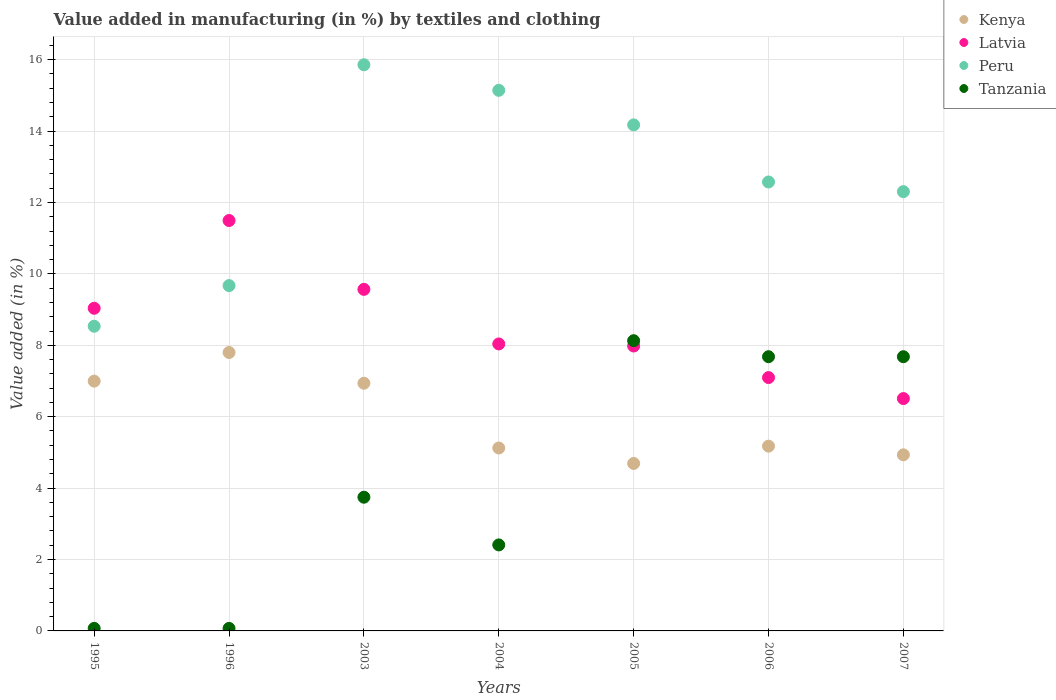How many different coloured dotlines are there?
Provide a short and direct response. 4. Is the number of dotlines equal to the number of legend labels?
Ensure brevity in your answer.  Yes. What is the percentage of value added in manufacturing by textiles and clothing in Latvia in 1996?
Give a very brief answer. 11.5. Across all years, what is the maximum percentage of value added in manufacturing by textiles and clothing in Latvia?
Ensure brevity in your answer.  11.5. Across all years, what is the minimum percentage of value added in manufacturing by textiles and clothing in Latvia?
Your response must be concise. 6.51. What is the total percentage of value added in manufacturing by textiles and clothing in Tanzania in the graph?
Keep it short and to the point. 29.79. What is the difference between the percentage of value added in manufacturing by textiles and clothing in Tanzania in 1995 and that in 2005?
Offer a very short reply. -8.06. What is the difference between the percentage of value added in manufacturing by textiles and clothing in Latvia in 1995 and the percentage of value added in manufacturing by textiles and clothing in Tanzania in 2007?
Ensure brevity in your answer.  1.36. What is the average percentage of value added in manufacturing by textiles and clothing in Tanzania per year?
Ensure brevity in your answer.  4.26. In the year 1996, what is the difference between the percentage of value added in manufacturing by textiles and clothing in Peru and percentage of value added in manufacturing by textiles and clothing in Kenya?
Your response must be concise. 1.87. What is the ratio of the percentage of value added in manufacturing by textiles and clothing in Kenya in 1995 to that in 2004?
Your answer should be very brief. 1.37. What is the difference between the highest and the second highest percentage of value added in manufacturing by textiles and clothing in Latvia?
Give a very brief answer. 1.93. What is the difference between the highest and the lowest percentage of value added in manufacturing by textiles and clothing in Tanzania?
Ensure brevity in your answer.  8.06. In how many years, is the percentage of value added in manufacturing by textiles and clothing in Latvia greater than the average percentage of value added in manufacturing by textiles and clothing in Latvia taken over all years?
Provide a succinct answer. 3. Is it the case that in every year, the sum of the percentage of value added in manufacturing by textiles and clothing in Peru and percentage of value added in manufacturing by textiles and clothing in Tanzania  is greater than the sum of percentage of value added in manufacturing by textiles and clothing in Latvia and percentage of value added in manufacturing by textiles and clothing in Kenya?
Keep it short and to the point. No. Does the percentage of value added in manufacturing by textiles and clothing in Peru monotonically increase over the years?
Ensure brevity in your answer.  No. Is the percentage of value added in manufacturing by textiles and clothing in Latvia strictly greater than the percentage of value added in manufacturing by textiles and clothing in Peru over the years?
Give a very brief answer. No. How many years are there in the graph?
Your response must be concise. 7. Are the values on the major ticks of Y-axis written in scientific E-notation?
Your answer should be very brief. No. Does the graph contain grids?
Keep it short and to the point. Yes. Where does the legend appear in the graph?
Offer a very short reply. Top right. How are the legend labels stacked?
Your answer should be very brief. Vertical. What is the title of the graph?
Offer a very short reply. Value added in manufacturing (in %) by textiles and clothing. Does "Bangladesh" appear as one of the legend labels in the graph?
Your response must be concise. No. What is the label or title of the X-axis?
Your answer should be very brief. Years. What is the label or title of the Y-axis?
Give a very brief answer. Value added (in %). What is the Value added (in %) of Kenya in 1995?
Provide a succinct answer. 7. What is the Value added (in %) in Latvia in 1995?
Your answer should be very brief. 9.04. What is the Value added (in %) in Peru in 1995?
Your answer should be compact. 8.53. What is the Value added (in %) in Tanzania in 1995?
Offer a terse response. 0.07. What is the Value added (in %) of Kenya in 1996?
Give a very brief answer. 7.8. What is the Value added (in %) in Latvia in 1996?
Offer a terse response. 11.5. What is the Value added (in %) in Peru in 1996?
Offer a very short reply. 9.67. What is the Value added (in %) in Tanzania in 1996?
Keep it short and to the point. 0.07. What is the Value added (in %) of Kenya in 2003?
Offer a very short reply. 6.94. What is the Value added (in %) in Latvia in 2003?
Keep it short and to the point. 9.57. What is the Value added (in %) in Peru in 2003?
Provide a succinct answer. 15.86. What is the Value added (in %) of Tanzania in 2003?
Your response must be concise. 3.74. What is the Value added (in %) in Kenya in 2004?
Give a very brief answer. 5.12. What is the Value added (in %) of Latvia in 2004?
Keep it short and to the point. 8.04. What is the Value added (in %) in Peru in 2004?
Your answer should be very brief. 15.14. What is the Value added (in %) of Tanzania in 2004?
Your answer should be compact. 2.41. What is the Value added (in %) of Kenya in 2005?
Ensure brevity in your answer.  4.69. What is the Value added (in %) of Latvia in 2005?
Make the answer very short. 7.98. What is the Value added (in %) of Peru in 2005?
Offer a very short reply. 14.17. What is the Value added (in %) of Tanzania in 2005?
Offer a very short reply. 8.13. What is the Value added (in %) in Kenya in 2006?
Make the answer very short. 5.18. What is the Value added (in %) in Latvia in 2006?
Give a very brief answer. 7.1. What is the Value added (in %) in Peru in 2006?
Keep it short and to the point. 12.57. What is the Value added (in %) of Tanzania in 2006?
Provide a succinct answer. 7.68. What is the Value added (in %) in Kenya in 2007?
Keep it short and to the point. 4.93. What is the Value added (in %) of Latvia in 2007?
Offer a very short reply. 6.51. What is the Value added (in %) in Peru in 2007?
Offer a very short reply. 12.3. What is the Value added (in %) in Tanzania in 2007?
Offer a terse response. 7.68. Across all years, what is the maximum Value added (in %) of Kenya?
Offer a terse response. 7.8. Across all years, what is the maximum Value added (in %) of Latvia?
Give a very brief answer. 11.5. Across all years, what is the maximum Value added (in %) of Peru?
Your answer should be very brief. 15.86. Across all years, what is the maximum Value added (in %) in Tanzania?
Your answer should be very brief. 8.13. Across all years, what is the minimum Value added (in %) in Kenya?
Provide a succinct answer. 4.69. Across all years, what is the minimum Value added (in %) of Latvia?
Your answer should be very brief. 6.51. Across all years, what is the minimum Value added (in %) in Peru?
Offer a very short reply. 8.53. Across all years, what is the minimum Value added (in %) of Tanzania?
Your response must be concise. 0.07. What is the total Value added (in %) of Kenya in the graph?
Your answer should be very brief. 41.65. What is the total Value added (in %) of Latvia in the graph?
Ensure brevity in your answer.  59.72. What is the total Value added (in %) of Peru in the graph?
Ensure brevity in your answer.  88.26. What is the total Value added (in %) in Tanzania in the graph?
Offer a very short reply. 29.79. What is the difference between the Value added (in %) of Kenya in 1995 and that in 1996?
Provide a short and direct response. -0.8. What is the difference between the Value added (in %) of Latvia in 1995 and that in 1996?
Provide a short and direct response. -2.46. What is the difference between the Value added (in %) in Peru in 1995 and that in 1996?
Offer a very short reply. -1.14. What is the difference between the Value added (in %) of Tanzania in 1995 and that in 1996?
Keep it short and to the point. 0. What is the difference between the Value added (in %) of Kenya in 1995 and that in 2003?
Your answer should be very brief. 0.06. What is the difference between the Value added (in %) in Latvia in 1995 and that in 2003?
Make the answer very short. -0.53. What is the difference between the Value added (in %) in Peru in 1995 and that in 2003?
Your answer should be compact. -7.32. What is the difference between the Value added (in %) of Tanzania in 1995 and that in 2003?
Make the answer very short. -3.67. What is the difference between the Value added (in %) of Kenya in 1995 and that in 2004?
Your answer should be compact. 1.87. What is the difference between the Value added (in %) of Latvia in 1995 and that in 2004?
Your response must be concise. 1. What is the difference between the Value added (in %) in Peru in 1995 and that in 2004?
Offer a terse response. -6.61. What is the difference between the Value added (in %) of Tanzania in 1995 and that in 2004?
Provide a succinct answer. -2.34. What is the difference between the Value added (in %) of Kenya in 1995 and that in 2005?
Provide a succinct answer. 2.31. What is the difference between the Value added (in %) of Latvia in 1995 and that in 2005?
Provide a succinct answer. 1.06. What is the difference between the Value added (in %) in Peru in 1995 and that in 2005?
Your response must be concise. -5.64. What is the difference between the Value added (in %) of Tanzania in 1995 and that in 2005?
Your answer should be compact. -8.06. What is the difference between the Value added (in %) in Kenya in 1995 and that in 2006?
Ensure brevity in your answer.  1.82. What is the difference between the Value added (in %) in Latvia in 1995 and that in 2006?
Provide a succinct answer. 1.94. What is the difference between the Value added (in %) in Peru in 1995 and that in 2006?
Make the answer very short. -4.04. What is the difference between the Value added (in %) of Tanzania in 1995 and that in 2006?
Ensure brevity in your answer.  -7.61. What is the difference between the Value added (in %) of Kenya in 1995 and that in 2007?
Make the answer very short. 2.06. What is the difference between the Value added (in %) in Latvia in 1995 and that in 2007?
Provide a short and direct response. 2.53. What is the difference between the Value added (in %) in Peru in 1995 and that in 2007?
Ensure brevity in your answer.  -3.77. What is the difference between the Value added (in %) of Tanzania in 1995 and that in 2007?
Your answer should be very brief. -7.61. What is the difference between the Value added (in %) of Kenya in 1996 and that in 2003?
Your answer should be very brief. 0.86. What is the difference between the Value added (in %) in Latvia in 1996 and that in 2003?
Offer a terse response. 1.93. What is the difference between the Value added (in %) of Peru in 1996 and that in 2003?
Keep it short and to the point. -6.19. What is the difference between the Value added (in %) of Tanzania in 1996 and that in 2003?
Your answer should be compact. -3.67. What is the difference between the Value added (in %) of Kenya in 1996 and that in 2004?
Your response must be concise. 2.67. What is the difference between the Value added (in %) in Latvia in 1996 and that in 2004?
Make the answer very short. 3.46. What is the difference between the Value added (in %) of Peru in 1996 and that in 2004?
Provide a succinct answer. -5.47. What is the difference between the Value added (in %) in Tanzania in 1996 and that in 2004?
Give a very brief answer. -2.34. What is the difference between the Value added (in %) of Kenya in 1996 and that in 2005?
Give a very brief answer. 3.11. What is the difference between the Value added (in %) of Latvia in 1996 and that in 2005?
Make the answer very short. 3.51. What is the difference between the Value added (in %) of Peru in 1996 and that in 2005?
Offer a very short reply. -4.5. What is the difference between the Value added (in %) in Tanzania in 1996 and that in 2005?
Offer a terse response. -8.06. What is the difference between the Value added (in %) of Kenya in 1996 and that in 2006?
Offer a terse response. 2.62. What is the difference between the Value added (in %) in Latvia in 1996 and that in 2006?
Provide a short and direct response. 4.4. What is the difference between the Value added (in %) in Peru in 1996 and that in 2006?
Keep it short and to the point. -2.9. What is the difference between the Value added (in %) in Tanzania in 1996 and that in 2006?
Offer a terse response. -7.61. What is the difference between the Value added (in %) of Kenya in 1996 and that in 2007?
Your answer should be compact. 2.87. What is the difference between the Value added (in %) in Latvia in 1996 and that in 2007?
Give a very brief answer. 4.99. What is the difference between the Value added (in %) of Peru in 1996 and that in 2007?
Ensure brevity in your answer.  -2.63. What is the difference between the Value added (in %) in Tanzania in 1996 and that in 2007?
Make the answer very short. -7.61. What is the difference between the Value added (in %) in Kenya in 2003 and that in 2004?
Your answer should be compact. 1.81. What is the difference between the Value added (in %) in Latvia in 2003 and that in 2004?
Your answer should be compact. 1.53. What is the difference between the Value added (in %) in Peru in 2003 and that in 2004?
Provide a short and direct response. 0.72. What is the difference between the Value added (in %) of Tanzania in 2003 and that in 2004?
Your response must be concise. 1.34. What is the difference between the Value added (in %) in Kenya in 2003 and that in 2005?
Your answer should be very brief. 2.25. What is the difference between the Value added (in %) of Latvia in 2003 and that in 2005?
Your answer should be compact. 1.59. What is the difference between the Value added (in %) in Peru in 2003 and that in 2005?
Your answer should be very brief. 1.68. What is the difference between the Value added (in %) of Tanzania in 2003 and that in 2005?
Your response must be concise. -4.38. What is the difference between the Value added (in %) in Kenya in 2003 and that in 2006?
Offer a terse response. 1.76. What is the difference between the Value added (in %) of Latvia in 2003 and that in 2006?
Keep it short and to the point. 2.47. What is the difference between the Value added (in %) in Peru in 2003 and that in 2006?
Your answer should be compact. 3.28. What is the difference between the Value added (in %) in Tanzania in 2003 and that in 2006?
Your answer should be very brief. -3.94. What is the difference between the Value added (in %) of Kenya in 2003 and that in 2007?
Your answer should be compact. 2.01. What is the difference between the Value added (in %) in Latvia in 2003 and that in 2007?
Your answer should be compact. 3.06. What is the difference between the Value added (in %) of Peru in 2003 and that in 2007?
Give a very brief answer. 3.55. What is the difference between the Value added (in %) of Tanzania in 2003 and that in 2007?
Ensure brevity in your answer.  -3.94. What is the difference between the Value added (in %) in Kenya in 2004 and that in 2005?
Offer a very short reply. 0.43. What is the difference between the Value added (in %) of Latvia in 2004 and that in 2005?
Offer a terse response. 0.06. What is the difference between the Value added (in %) in Tanzania in 2004 and that in 2005?
Offer a very short reply. -5.72. What is the difference between the Value added (in %) of Kenya in 2004 and that in 2006?
Make the answer very short. -0.05. What is the difference between the Value added (in %) in Latvia in 2004 and that in 2006?
Offer a very short reply. 0.94. What is the difference between the Value added (in %) of Peru in 2004 and that in 2006?
Your answer should be compact. 2.57. What is the difference between the Value added (in %) in Tanzania in 2004 and that in 2006?
Give a very brief answer. -5.27. What is the difference between the Value added (in %) in Kenya in 2004 and that in 2007?
Give a very brief answer. 0.19. What is the difference between the Value added (in %) of Latvia in 2004 and that in 2007?
Your response must be concise. 1.53. What is the difference between the Value added (in %) in Peru in 2004 and that in 2007?
Provide a short and direct response. 2.84. What is the difference between the Value added (in %) of Tanzania in 2004 and that in 2007?
Give a very brief answer. -5.27. What is the difference between the Value added (in %) of Kenya in 2005 and that in 2006?
Keep it short and to the point. -0.48. What is the difference between the Value added (in %) of Latvia in 2005 and that in 2006?
Provide a succinct answer. 0.88. What is the difference between the Value added (in %) in Peru in 2005 and that in 2006?
Offer a terse response. 1.6. What is the difference between the Value added (in %) of Tanzania in 2005 and that in 2006?
Your answer should be very brief. 0.45. What is the difference between the Value added (in %) in Kenya in 2005 and that in 2007?
Your response must be concise. -0.24. What is the difference between the Value added (in %) of Latvia in 2005 and that in 2007?
Give a very brief answer. 1.47. What is the difference between the Value added (in %) in Peru in 2005 and that in 2007?
Your answer should be compact. 1.87. What is the difference between the Value added (in %) of Tanzania in 2005 and that in 2007?
Make the answer very short. 0.45. What is the difference between the Value added (in %) in Kenya in 2006 and that in 2007?
Your response must be concise. 0.24. What is the difference between the Value added (in %) of Latvia in 2006 and that in 2007?
Your response must be concise. 0.59. What is the difference between the Value added (in %) of Peru in 2006 and that in 2007?
Your response must be concise. 0.27. What is the difference between the Value added (in %) of Kenya in 1995 and the Value added (in %) of Latvia in 1996?
Your response must be concise. -4.5. What is the difference between the Value added (in %) of Kenya in 1995 and the Value added (in %) of Peru in 1996?
Your answer should be very brief. -2.68. What is the difference between the Value added (in %) of Kenya in 1995 and the Value added (in %) of Tanzania in 1996?
Your response must be concise. 6.93. What is the difference between the Value added (in %) of Latvia in 1995 and the Value added (in %) of Peru in 1996?
Your answer should be compact. -0.63. What is the difference between the Value added (in %) of Latvia in 1995 and the Value added (in %) of Tanzania in 1996?
Offer a very short reply. 8.97. What is the difference between the Value added (in %) in Peru in 1995 and the Value added (in %) in Tanzania in 1996?
Make the answer very short. 8.46. What is the difference between the Value added (in %) in Kenya in 1995 and the Value added (in %) in Latvia in 2003?
Keep it short and to the point. -2.57. What is the difference between the Value added (in %) in Kenya in 1995 and the Value added (in %) in Peru in 2003?
Keep it short and to the point. -8.86. What is the difference between the Value added (in %) of Kenya in 1995 and the Value added (in %) of Tanzania in 2003?
Offer a very short reply. 3.25. What is the difference between the Value added (in %) in Latvia in 1995 and the Value added (in %) in Peru in 2003?
Provide a short and direct response. -6.82. What is the difference between the Value added (in %) of Latvia in 1995 and the Value added (in %) of Tanzania in 2003?
Your response must be concise. 5.29. What is the difference between the Value added (in %) in Peru in 1995 and the Value added (in %) in Tanzania in 2003?
Your answer should be compact. 4.79. What is the difference between the Value added (in %) of Kenya in 1995 and the Value added (in %) of Latvia in 2004?
Provide a succinct answer. -1.04. What is the difference between the Value added (in %) in Kenya in 1995 and the Value added (in %) in Peru in 2004?
Your response must be concise. -8.15. What is the difference between the Value added (in %) of Kenya in 1995 and the Value added (in %) of Tanzania in 2004?
Provide a succinct answer. 4.59. What is the difference between the Value added (in %) of Latvia in 1995 and the Value added (in %) of Peru in 2004?
Give a very brief answer. -6.1. What is the difference between the Value added (in %) of Latvia in 1995 and the Value added (in %) of Tanzania in 2004?
Your answer should be very brief. 6.63. What is the difference between the Value added (in %) in Peru in 1995 and the Value added (in %) in Tanzania in 2004?
Keep it short and to the point. 6.12. What is the difference between the Value added (in %) in Kenya in 1995 and the Value added (in %) in Latvia in 2005?
Ensure brevity in your answer.  -0.98. What is the difference between the Value added (in %) of Kenya in 1995 and the Value added (in %) of Peru in 2005?
Your answer should be very brief. -7.18. What is the difference between the Value added (in %) of Kenya in 1995 and the Value added (in %) of Tanzania in 2005?
Keep it short and to the point. -1.13. What is the difference between the Value added (in %) in Latvia in 1995 and the Value added (in %) in Peru in 2005?
Your answer should be very brief. -5.14. What is the difference between the Value added (in %) of Latvia in 1995 and the Value added (in %) of Tanzania in 2005?
Ensure brevity in your answer.  0.91. What is the difference between the Value added (in %) of Peru in 1995 and the Value added (in %) of Tanzania in 2005?
Offer a very short reply. 0.4. What is the difference between the Value added (in %) in Kenya in 1995 and the Value added (in %) in Peru in 2006?
Offer a terse response. -5.58. What is the difference between the Value added (in %) in Kenya in 1995 and the Value added (in %) in Tanzania in 2006?
Give a very brief answer. -0.68. What is the difference between the Value added (in %) of Latvia in 1995 and the Value added (in %) of Peru in 2006?
Ensure brevity in your answer.  -3.54. What is the difference between the Value added (in %) in Latvia in 1995 and the Value added (in %) in Tanzania in 2006?
Make the answer very short. 1.36. What is the difference between the Value added (in %) in Peru in 1995 and the Value added (in %) in Tanzania in 2006?
Give a very brief answer. 0.85. What is the difference between the Value added (in %) of Kenya in 1995 and the Value added (in %) of Latvia in 2007?
Your answer should be very brief. 0.49. What is the difference between the Value added (in %) of Kenya in 1995 and the Value added (in %) of Peru in 2007?
Keep it short and to the point. -5.31. What is the difference between the Value added (in %) of Kenya in 1995 and the Value added (in %) of Tanzania in 2007?
Offer a very short reply. -0.68. What is the difference between the Value added (in %) in Latvia in 1995 and the Value added (in %) in Peru in 2007?
Give a very brief answer. -3.27. What is the difference between the Value added (in %) of Latvia in 1995 and the Value added (in %) of Tanzania in 2007?
Give a very brief answer. 1.36. What is the difference between the Value added (in %) of Peru in 1995 and the Value added (in %) of Tanzania in 2007?
Make the answer very short. 0.85. What is the difference between the Value added (in %) of Kenya in 1996 and the Value added (in %) of Latvia in 2003?
Provide a short and direct response. -1.77. What is the difference between the Value added (in %) of Kenya in 1996 and the Value added (in %) of Peru in 2003?
Offer a very short reply. -8.06. What is the difference between the Value added (in %) of Kenya in 1996 and the Value added (in %) of Tanzania in 2003?
Your answer should be very brief. 4.05. What is the difference between the Value added (in %) in Latvia in 1996 and the Value added (in %) in Peru in 2003?
Provide a short and direct response. -4.36. What is the difference between the Value added (in %) of Latvia in 1996 and the Value added (in %) of Tanzania in 2003?
Provide a short and direct response. 7.75. What is the difference between the Value added (in %) in Peru in 1996 and the Value added (in %) in Tanzania in 2003?
Provide a succinct answer. 5.93. What is the difference between the Value added (in %) of Kenya in 1996 and the Value added (in %) of Latvia in 2004?
Provide a short and direct response. -0.24. What is the difference between the Value added (in %) in Kenya in 1996 and the Value added (in %) in Peru in 2004?
Offer a terse response. -7.34. What is the difference between the Value added (in %) of Kenya in 1996 and the Value added (in %) of Tanzania in 2004?
Your answer should be compact. 5.39. What is the difference between the Value added (in %) of Latvia in 1996 and the Value added (in %) of Peru in 2004?
Make the answer very short. -3.65. What is the difference between the Value added (in %) in Latvia in 1996 and the Value added (in %) in Tanzania in 2004?
Offer a very short reply. 9.09. What is the difference between the Value added (in %) of Peru in 1996 and the Value added (in %) of Tanzania in 2004?
Ensure brevity in your answer.  7.26. What is the difference between the Value added (in %) in Kenya in 1996 and the Value added (in %) in Latvia in 2005?
Give a very brief answer. -0.18. What is the difference between the Value added (in %) of Kenya in 1996 and the Value added (in %) of Peru in 2005?
Keep it short and to the point. -6.37. What is the difference between the Value added (in %) of Kenya in 1996 and the Value added (in %) of Tanzania in 2005?
Offer a very short reply. -0.33. What is the difference between the Value added (in %) in Latvia in 1996 and the Value added (in %) in Peru in 2005?
Give a very brief answer. -2.68. What is the difference between the Value added (in %) in Latvia in 1996 and the Value added (in %) in Tanzania in 2005?
Provide a short and direct response. 3.37. What is the difference between the Value added (in %) in Peru in 1996 and the Value added (in %) in Tanzania in 2005?
Provide a succinct answer. 1.54. What is the difference between the Value added (in %) of Kenya in 1996 and the Value added (in %) of Latvia in 2006?
Provide a short and direct response. 0.7. What is the difference between the Value added (in %) in Kenya in 1996 and the Value added (in %) in Peru in 2006?
Offer a terse response. -4.78. What is the difference between the Value added (in %) of Kenya in 1996 and the Value added (in %) of Tanzania in 2006?
Provide a succinct answer. 0.12. What is the difference between the Value added (in %) of Latvia in 1996 and the Value added (in %) of Peru in 2006?
Provide a short and direct response. -1.08. What is the difference between the Value added (in %) in Latvia in 1996 and the Value added (in %) in Tanzania in 2006?
Keep it short and to the point. 3.81. What is the difference between the Value added (in %) of Peru in 1996 and the Value added (in %) of Tanzania in 2006?
Offer a terse response. 1.99. What is the difference between the Value added (in %) of Kenya in 1996 and the Value added (in %) of Latvia in 2007?
Your answer should be compact. 1.29. What is the difference between the Value added (in %) of Kenya in 1996 and the Value added (in %) of Peru in 2007?
Offer a terse response. -4.5. What is the difference between the Value added (in %) of Kenya in 1996 and the Value added (in %) of Tanzania in 2007?
Provide a succinct answer. 0.12. What is the difference between the Value added (in %) of Latvia in 1996 and the Value added (in %) of Peru in 2007?
Offer a terse response. -0.81. What is the difference between the Value added (in %) of Latvia in 1996 and the Value added (in %) of Tanzania in 2007?
Ensure brevity in your answer.  3.81. What is the difference between the Value added (in %) in Peru in 1996 and the Value added (in %) in Tanzania in 2007?
Offer a very short reply. 1.99. What is the difference between the Value added (in %) in Kenya in 2003 and the Value added (in %) in Latvia in 2004?
Ensure brevity in your answer.  -1.1. What is the difference between the Value added (in %) of Kenya in 2003 and the Value added (in %) of Peru in 2004?
Offer a terse response. -8.2. What is the difference between the Value added (in %) of Kenya in 2003 and the Value added (in %) of Tanzania in 2004?
Make the answer very short. 4.53. What is the difference between the Value added (in %) in Latvia in 2003 and the Value added (in %) in Peru in 2004?
Offer a terse response. -5.57. What is the difference between the Value added (in %) of Latvia in 2003 and the Value added (in %) of Tanzania in 2004?
Give a very brief answer. 7.16. What is the difference between the Value added (in %) in Peru in 2003 and the Value added (in %) in Tanzania in 2004?
Offer a terse response. 13.45. What is the difference between the Value added (in %) of Kenya in 2003 and the Value added (in %) of Latvia in 2005?
Your answer should be compact. -1.04. What is the difference between the Value added (in %) of Kenya in 2003 and the Value added (in %) of Peru in 2005?
Your answer should be very brief. -7.24. What is the difference between the Value added (in %) of Kenya in 2003 and the Value added (in %) of Tanzania in 2005?
Make the answer very short. -1.19. What is the difference between the Value added (in %) of Latvia in 2003 and the Value added (in %) of Peru in 2005?
Ensure brevity in your answer.  -4.61. What is the difference between the Value added (in %) in Latvia in 2003 and the Value added (in %) in Tanzania in 2005?
Your answer should be compact. 1.44. What is the difference between the Value added (in %) of Peru in 2003 and the Value added (in %) of Tanzania in 2005?
Make the answer very short. 7.73. What is the difference between the Value added (in %) of Kenya in 2003 and the Value added (in %) of Latvia in 2006?
Your response must be concise. -0.16. What is the difference between the Value added (in %) of Kenya in 2003 and the Value added (in %) of Peru in 2006?
Offer a terse response. -5.64. What is the difference between the Value added (in %) in Kenya in 2003 and the Value added (in %) in Tanzania in 2006?
Offer a terse response. -0.74. What is the difference between the Value added (in %) of Latvia in 2003 and the Value added (in %) of Peru in 2006?
Offer a very short reply. -3.01. What is the difference between the Value added (in %) of Latvia in 2003 and the Value added (in %) of Tanzania in 2006?
Offer a terse response. 1.89. What is the difference between the Value added (in %) of Peru in 2003 and the Value added (in %) of Tanzania in 2006?
Give a very brief answer. 8.18. What is the difference between the Value added (in %) in Kenya in 2003 and the Value added (in %) in Latvia in 2007?
Provide a succinct answer. 0.43. What is the difference between the Value added (in %) in Kenya in 2003 and the Value added (in %) in Peru in 2007?
Your answer should be compact. -5.37. What is the difference between the Value added (in %) of Kenya in 2003 and the Value added (in %) of Tanzania in 2007?
Keep it short and to the point. -0.74. What is the difference between the Value added (in %) in Latvia in 2003 and the Value added (in %) in Peru in 2007?
Keep it short and to the point. -2.74. What is the difference between the Value added (in %) of Latvia in 2003 and the Value added (in %) of Tanzania in 2007?
Ensure brevity in your answer.  1.89. What is the difference between the Value added (in %) in Peru in 2003 and the Value added (in %) in Tanzania in 2007?
Your answer should be compact. 8.18. What is the difference between the Value added (in %) of Kenya in 2004 and the Value added (in %) of Latvia in 2005?
Your answer should be very brief. -2.86. What is the difference between the Value added (in %) of Kenya in 2004 and the Value added (in %) of Peru in 2005?
Your answer should be very brief. -9.05. What is the difference between the Value added (in %) of Kenya in 2004 and the Value added (in %) of Tanzania in 2005?
Make the answer very short. -3.01. What is the difference between the Value added (in %) in Latvia in 2004 and the Value added (in %) in Peru in 2005?
Keep it short and to the point. -6.14. What is the difference between the Value added (in %) in Latvia in 2004 and the Value added (in %) in Tanzania in 2005?
Your response must be concise. -0.09. What is the difference between the Value added (in %) in Peru in 2004 and the Value added (in %) in Tanzania in 2005?
Give a very brief answer. 7.01. What is the difference between the Value added (in %) in Kenya in 2004 and the Value added (in %) in Latvia in 2006?
Offer a very short reply. -1.97. What is the difference between the Value added (in %) in Kenya in 2004 and the Value added (in %) in Peru in 2006?
Provide a succinct answer. -7.45. What is the difference between the Value added (in %) of Kenya in 2004 and the Value added (in %) of Tanzania in 2006?
Ensure brevity in your answer.  -2.56. What is the difference between the Value added (in %) in Latvia in 2004 and the Value added (in %) in Peru in 2006?
Give a very brief answer. -4.54. What is the difference between the Value added (in %) of Latvia in 2004 and the Value added (in %) of Tanzania in 2006?
Ensure brevity in your answer.  0.36. What is the difference between the Value added (in %) of Peru in 2004 and the Value added (in %) of Tanzania in 2006?
Provide a succinct answer. 7.46. What is the difference between the Value added (in %) of Kenya in 2004 and the Value added (in %) of Latvia in 2007?
Keep it short and to the point. -1.38. What is the difference between the Value added (in %) of Kenya in 2004 and the Value added (in %) of Peru in 2007?
Your answer should be very brief. -7.18. What is the difference between the Value added (in %) of Kenya in 2004 and the Value added (in %) of Tanzania in 2007?
Your response must be concise. -2.56. What is the difference between the Value added (in %) in Latvia in 2004 and the Value added (in %) in Peru in 2007?
Ensure brevity in your answer.  -4.27. What is the difference between the Value added (in %) of Latvia in 2004 and the Value added (in %) of Tanzania in 2007?
Ensure brevity in your answer.  0.36. What is the difference between the Value added (in %) in Peru in 2004 and the Value added (in %) in Tanzania in 2007?
Your answer should be compact. 7.46. What is the difference between the Value added (in %) in Kenya in 2005 and the Value added (in %) in Latvia in 2006?
Your answer should be very brief. -2.41. What is the difference between the Value added (in %) of Kenya in 2005 and the Value added (in %) of Peru in 2006?
Ensure brevity in your answer.  -7.88. What is the difference between the Value added (in %) of Kenya in 2005 and the Value added (in %) of Tanzania in 2006?
Keep it short and to the point. -2.99. What is the difference between the Value added (in %) of Latvia in 2005 and the Value added (in %) of Peru in 2006?
Provide a succinct answer. -4.59. What is the difference between the Value added (in %) of Latvia in 2005 and the Value added (in %) of Tanzania in 2006?
Make the answer very short. 0.3. What is the difference between the Value added (in %) in Peru in 2005 and the Value added (in %) in Tanzania in 2006?
Provide a short and direct response. 6.49. What is the difference between the Value added (in %) in Kenya in 2005 and the Value added (in %) in Latvia in 2007?
Provide a short and direct response. -1.82. What is the difference between the Value added (in %) in Kenya in 2005 and the Value added (in %) in Peru in 2007?
Provide a succinct answer. -7.61. What is the difference between the Value added (in %) of Kenya in 2005 and the Value added (in %) of Tanzania in 2007?
Your response must be concise. -2.99. What is the difference between the Value added (in %) in Latvia in 2005 and the Value added (in %) in Peru in 2007?
Make the answer very short. -4.32. What is the difference between the Value added (in %) of Latvia in 2005 and the Value added (in %) of Tanzania in 2007?
Your answer should be compact. 0.3. What is the difference between the Value added (in %) of Peru in 2005 and the Value added (in %) of Tanzania in 2007?
Offer a very short reply. 6.49. What is the difference between the Value added (in %) in Kenya in 2006 and the Value added (in %) in Latvia in 2007?
Provide a succinct answer. -1.33. What is the difference between the Value added (in %) of Kenya in 2006 and the Value added (in %) of Peru in 2007?
Provide a succinct answer. -7.13. What is the difference between the Value added (in %) in Kenya in 2006 and the Value added (in %) in Tanzania in 2007?
Your answer should be compact. -2.51. What is the difference between the Value added (in %) of Latvia in 2006 and the Value added (in %) of Peru in 2007?
Keep it short and to the point. -5.21. What is the difference between the Value added (in %) of Latvia in 2006 and the Value added (in %) of Tanzania in 2007?
Give a very brief answer. -0.58. What is the difference between the Value added (in %) in Peru in 2006 and the Value added (in %) in Tanzania in 2007?
Make the answer very short. 4.89. What is the average Value added (in %) in Kenya per year?
Your response must be concise. 5.95. What is the average Value added (in %) of Latvia per year?
Your answer should be very brief. 8.53. What is the average Value added (in %) in Peru per year?
Offer a terse response. 12.61. What is the average Value added (in %) in Tanzania per year?
Provide a succinct answer. 4.25. In the year 1995, what is the difference between the Value added (in %) in Kenya and Value added (in %) in Latvia?
Your answer should be compact. -2.04. In the year 1995, what is the difference between the Value added (in %) in Kenya and Value added (in %) in Peru?
Give a very brief answer. -1.54. In the year 1995, what is the difference between the Value added (in %) in Kenya and Value added (in %) in Tanzania?
Offer a very short reply. 6.93. In the year 1995, what is the difference between the Value added (in %) of Latvia and Value added (in %) of Peru?
Make the answer very short. 0.5. In the year 1995, what is the difference between the Value added (in %) of Latvia and Value added (in %) of Tanzania?
Your response must be concise. 8.97. In the year 1995, what is the difference between the Value added (in %) of Peru and Value added (in %) of Tanzania?
Your answer should be very brief. 8.46. In the year 1996, what is the difference between the Value added (in %) in Kenya and Value added (in %) in Latvia?
Offer a very short reply. -3.7. In the year 1996, what is the difference between the Value added (in %) of Kenya and Value added (in %) of Peru?
Offer a very short reply. -1.87. In the year 1996, what is the difference between the Value added (in %) in Kenya and Value added (in %) in Tanzania?
Provide a short and direct response. 7.73. In the year 1996, what is the difference between the Value added (in %) in Latvia and Value added (in %) in Peru?
Ensure brevity in your answer.  1.82. In the year 1996, what is the difference between the Value added (in %) in Latvia and Value added (in %) in Tanzania?
Provide a short and direct response. 11.42. In the year 1996, what is the difference between the Value added (in %) of Peru and Value added (in %) of Tanzania?
Ensure brevity in your answer.  9.6. In the year 2003, what is the difference between the Value added (in %) of Kenya and Value added (in %) of Latvia?
Provide a short and direct response. -2.63. In the year 2003, what is the difference between the Value added (in %) in Kenya and Value added (in %) in Peru?
Make the answer very short. -8.92. In the year 2003, what is the difference between the Value added (in %) in Kenya and Value added (in %) in Tanzania?
Your response must be concise. 3.19. In the year 2003, what is the difference between the Value added (in %) of Latvia and Value added (in %) of Peru?
Give a very brief answer. -6.29. In the year 2003, what is the difference between the Value added (in %) of Latvia and Value added (in %) of Tanzania?
Keep it short and to the point. 5.82. In the year 2003, what is the difference between the Value added (in %) of Peru and Value added (in %) of Tanzania?
Ensure brevity in your answer.  12.11. In the year 2004, what is the difference between the Value added (in %) of Kenya and Value added (in %) of Latvia?
Provide a succinct answer. -2.91. In the year 2004, what is the difference between the Value added (in %) in Kenya and Value added (in %) in Peru?
Make the answer very short. -10.02. In the year 2004, what is the difference between the Value added (in %) in Kenya and Value added (in %) in Tanzania?
Offer a very short reply. 2.71. In the year 2004, what is the difference between the Value added (in %) of Latvia and Value added (in %) of Peru?
Your response must be concise. -7.1. In the year 2004, what is the difference between the Value added (in %) in Latvia and Value added (in %) in Tanzania?
Ensure brevity in your answer.  5.63. In the year 2004, what is the difference between the Value added (in %) of Peru and Value added (in %) of Tanzania?
Give a very brief answer. 12.73. In the year 2005, what is the difference between the Value added (in %) of Kenya and Value added (in %) of Latvia?
Ensure brevity in your answer.  -3.29. In the year 2005, what is the difference between the Value added (in %) of Kenya and Value added (in %) of Peru?
Your answer should be very brief. -9.48. In the year 2005, what is the difference between the Value added (in %) of Kenya and Value added (in %) of Tanzania?
Keep it short and to the point. -3.44. In the year 2005, what is the difference between the Value added (in %) in Latvia and Value added (in %) in Peru?
Your answer should be very brief. -6.19. In the year 2005, what is the difference between the Value added (in %) in Latvia and Value added (in %) in Tanzania?
Your response must be concise. -0.15. In the year 2005, what is the difference between the Value added (in %) of Peru and Value added (in %) of Tanzania?
Provide a succinct answer. 6.04. In the year 2006, what is the difference between the Value added (in %) of Kenya and Value added (in %) of Latvia?
Make the answer very short. -1.92. In the year 2006, what is the difference between the Value added (in %) of Kenya and Value added (in %) of Peru?
Your answer should be compact. -7.4. In the year 2006, what is the difference between the Value added (in %) of Kenya and Value added (in %) of Tanzania?
Your answer should be compact. -2.51. In the year 2006, what is the difference between the Value added (in %) of Latvia and Value added (in %) of Peru?
Offer a terse response. -5.48. In the year 2006, what is the difference between the Value added (in %) of Latvia and Value added (in %) of Tanzania?
Provide a succinct answer. -0.58. In the year 2006, what is the difference between the Value added (in %) in Peru and Value added (in %) in Tanzania?
Make the answer very short. 4.89. In the year 2007, what is the difference between the Value added (in %) in Kenya and Value added (in %) in Latvia?
Ensure brevity in your answer.  -1.58. In the year 2007, what is the difference between the Value added (in %) in Kenya and Value added (in %) in Peru?
Your answer should be compact. -7.37. In the year 2007, what is the difference between the Value added (in %) of Kenya and Value added (in %) of Tanzania?
Keep it short and to the point. -2.75. In the year 2007, what is the difference between the Value added (in %) in Latvia and Value added (in %) in Peru?
Offer a terse response. -5.8. In the year 2007, what is the difference between the Value added (in %) of Latvia and Value added (in %) of Tanzania?
Ensure brevity in your answer.  -1.17. In the year 2007, what is the difference between the Value added (in %) of Peru and Value added (in %) of Tanzania?
Offer a very short reply. 4.62. What is the ratio of the Value added (in %) in Kenya in 1995 to that in 1996?
Your answer should be very brief. 0.9. What is the ratio of the Value added (in %) in Latvia in 1995 to that in 1996?
Provide a succinct answer. 0.79. What is the ratio of the Value added (in %) of Peru in 1995 to that in 1996?
Provide a short and direct response. 0.88. What is the ratio of the Value added (in %) of Kenya in 1995 to that in 2003?
Your answer should be very brief. 1.01. What is the ratio of the Value added (in %) of Latvia in 1995 to that in 2003?
Offer a very short reply. 0.94. What is the ratio of the Value added (in %) of Peru in 1995 to that in 2003?
Your answer should be very brief. 0.54. What is the ratio of the Value added (in %) in Tanzania in 1995 to that in 2003?
Give a very brief answer. 0.02. What is the ratio of the Value added (in %) of Kenya in 1995 to that in 2004?
Provide a succinct answer. 1.37. What is the ratio of the Value added (in %) in Latvia in 1995 to that in 2004?
Provide a succinct answer. 1.12. What is the ratio of the Value added (in %) of Peru in 1995 to that in 2004?
Give a very brief answer. 0.56. What is the ratio of the Value added (in %) in Tanzania in 1995 to that in 2004?
Provide a succinct answer. 0.03. What is the ratio of the Value added (in %) of Kenya in 1995 to that in 2005?
Provide a succinct answer. 1.49. What is the ratio of the Value added (in %) in Latvia in 1995 to that in 2005?
Your response must be concise. 1.13. What is the ratio of the Value added (in %) of Peru in 1995 to that in 2005?
Your answer should be very brief. 0.6. What is the ratio of the Value added (in %) of Tanzania in 1995 to that in 2005?
Your answer should be very brief. 0.01. What is the ratio of the Value added (in %) of Kenya in 1995 to that in 2006?
Your answer should be very brief. 1.35. What is the ratio of the Value added (in %) in Latvia in 1995 to that in 2006?
Offer a terse response. 1.27. What is the ratio of the Value added (in %) in Peru in 1995 to that in 2006?
Keep it short and to the point. 0.68. What is the ratio of the Value added (in %) of Tanzania in 1995 to that in 2006?
Make the answer very short. 0.01. What is the ratio of the Value added (in %) in Kenya in 1995 to that in 2007?
Your answer should be compact. 1.42. What is the ratio of the Value added (in %) of Latvia in 1995 to that in 2007?
Give a very brief answer. 1.39. What is the ratio of the Value added (in %) in Peru in 1995 to that in 2007?
Ensure brevity in your answer.  0.69. What is the ratio of the Value added (in %) of Tanzania in 1995 to that in 2007?
Provide a short and direct response. 0.01. What is the ratio of the Value added (in %) in Kenya in 1996 to that in 2003?
Ensure brevity in your answer.  1.12. What is the ratio of the Value added (in %) of Latvia in 1996 to that in 2003?
Give a very brief answer. 1.2. What is the ratio of the Value added (in %) of Peru in 1996 to that in 2003?
Keep it short and to the point. 0.61. What is the ratio of the Value added (in %) in Tanzania in 1996 to that in 2003?
Offer a terse response. 0.02. What is the ratio of the Value added (in %) of Kenya in 1996 to that in 2004?
Keep it short and to the point. 1.52. What is the ratio of the Value added (in %) of Latvia in 1996 to that in 2004?
Offer a very short reply. 1.43. What is the ratio of the Value added (in %) in Peru in 1996 to that in 2004?
Your answer should be very brief. 0.64. What is the ratio of the Value added (in %) of Tanzania in 1996 to that in 2004?
Your answer should be very brief. 0.03. What is the ratio of the Value added (in %) in Kenya in 1996 to that in 2005?
Ensure brevity in your answer.  1.66. What is the ratio of the Value added (in %) of Latvia in 1996 to that in 2005?
Your answer should be very brief. 1.44. What is the ratio of the Value added (in %) of Peru in 1996 to that in 2005?
Your response must be concise. 0.68. What is the ratio of the Value added (in %) of Tanzania in 1996 to that in 2005?
Your answer should be compact. 0.01. What is the ratio of the Value added (in %) of Kenya in 1996 to that in 2006?
Make the answer very short. 1.51. What is the ratio of the Value added (in %) in Latvia in 1996 to that in 2006?
Your answer should be compact. 1.62. What is the ratio of the Value added (in %) of Peru in 1996 to that in 2006?
Give a very brief answer. 0.77. What is the ratio of the Value added (in %) of Tanzania in 1996 to that in 2006?
Make the answer very short. 0.01. What is the ratio of the Value added (in %) in Kenya in 1996 to that in 2007?
Offer a terse response. 1.58. What is the ratio of the Value added (in %) of Latvia in 1996 to that in 2007?
Ensure brevity in your answer.  1.77. What is the ratio of the Value added (in %) in Peru in 1996 to that in 2007?
Provide a succinct answer. 0.79. What is the ratio of the Value added (in %) in Tanzania in 1996 to that in 2007?
Your answer should be compact. 0.01. What is the ratio of the Value added (in %) in Kenya in 2003 to that in 2004?
Provide a succinct answer. 1.35. What is the ratio of the Value added (in %) of Latvia in 2003 to that in 2004?
Your answer should be compact. 1.19. What is the ratio of the Value added (in %) of Peru in 2003 to that in 2004?
Offer a very short reply. 1.05. What is the ratio of the Value added (in %) of Tanzania in 2003 to that in 2004?
Give a very brief answer. 1.55. What is the ratio of the Value added (in %) in Kenya in 2003 to that in 2005?
Provide a succinct answer. 1.48. What is the ratio of the Value added (in %) of Latvia in 2003 to that in 2005?
Offer a very short reply. 1.2. What is the ratio of the Value added (in %) in Peru in 2003 to that in 2005?
Offer a very short reply. 1.12. What is the ratio of the Value added (in %) of Tanzania in 2003 to that in 2005?
Ensure brevity in your answer.  0.46. What is the ratio of the Value added (in %) of Kenya in 2003 to that in 2006?
Your response must be concise. 1.34. What is the ratio of the Value added (in %) of Latvia in 2003 to that in 2006?
Give a very brief answer. 1.35. What is the ratio of the Value added (in %) in Peru in 2003 to that in 2006?
Offer a terse response. 1.26. What is the ratio of the Value added (in %) of Tanzania in 2003 to that in 2006?
Your answer should be very brief. 0.49. What is the ratio of the Value added (in %) in Kenya in 2003 to that in 2007?
Your answer should be very brief. 1.41. What is the ratio of the Value added (in %) of Latvia in 2003 to that in 2007?
Provide a short and direct response. 1.47. What is the ratio of the Value added (in %) in Peru in 2003 to that in 2007?
Your answer should be very brief. 1.29. What is the ratio of the Value added (in %) of Tanzania in 2003 to that in 2007?
Give a very brief answer. 0.49. What is the ratio of the Value added (in %) in Kenya in 2004 to that in 2005?
Provide a succinct answer. 1.09. What is the ratio of the Value added (in %) in Latvia in 2004 to that in 2005?
Make the answer very short. 1.01. What is the ratio of the Value added (in %) in Peru in 2004 to that in 2005?
Provide a short and direct response. 1.07. What is the ratio of the Value added (in %) in Tanzania in 2004 to that in 2005?
Keep it short and to the point. 0.3. What is the ratio of the Value added (in %) in Kenya in 2004 to that in 2006?
Your response must be concise. 0.99. What is the ratio of the Value added (in %) in Latvia in 2004 to that in 2006?
Your answer should be very brief. 1.13. What is the ratio of the Value added (in %) of Peru in 2004 to that in 2006?
Offer a terse response. 1.2. What is the ratio of the Value added (in %) in Tanzania in 2004 to that in 2006?
Provide a short and direct response. 0.31. What is the ratio of the Value added (in %) of Kenya in 2004 to that in 2007?
Make the answer very short. 1.04. What is the ratio of the Value added (in %) in Latvia in 2004 to that in 2007?
Ensure brevity in your answer.  1.24. What is the ratio of the Value added (in %) in Peru in 2004 to that in 2007?
Offer a very short reply. 1.23. What is the ratio of the Value added (in %) in Tanzania in 2004 to that in 2007?
Keep it short and to the point. 0.31. What is the ratio of the Value added (in %) in Kenya in 2005 to that in 2006?
Ensure brevity in your answer.  0.91. What is the ratio of the Value added (in %) in Latvia in 2005 to that in 2006?
Provide a succinct answer. 1.12. What is the ratio of the Value added (in %) of Peru in 2005 to that in 2006?
Your response must be concise. 1.13. What is the ratio of the Value added (in %) in Tanzania in 2005 to that in 2006?
Give a very brief answer. 1.06. What is the ratio of the Value added (in %) in Kenya in 2005 to that in 2007?
Your response must be concise. 0.95. What is the ratio of the Value added (in %) in Latvia in 2005 to that in 2007?
Provide a succinct answer. 1.23. What is the ratio of the Value added (in %) of Peru in 2005 to that in 2007?
Offer a terse response. 1.15. What is the ratio of the Value added (in %) in Tanzania in 2005 to that in 2007?
Give a very brief answer. 1.06. What is the ratio of the Value added (in %) in Kenya in 2006 to that in 2007?
Offer a terse response. 1.05. What is the ratio of the Value added (in %) of Latvia in 2006 to that in 2007?
Offer a very short reply. 1.09. What is the difference between the highest and the second highest Value added (in %) of Kenya?
Provide a succinct answer. 0.8. What is the difference between the highest and the second highest Value added (in %) of Latvia?
Keep it short and to the point. 1.93. What is the difference between the highest and the second highest Value added (in %) of Peru?
Ensure brevity in your answer.  0.72. What is the difference between the highest and the second highest Value added (in %) in Tanzania?
Offer a very short reply. 0.45. What is the difference between the highest and the lowest Value added (in %) in Kenya?
Your response must be concise. 3.11. What is the difference between the highest and the lowest Value added (in %) of Latvia?
Your response must be concise. 4.99. What is the difference between the highest and the lowest Value added (in %) of Peru?
Provide a short and direct response. 7.32. What is the difference between the highest and the lowest Value added (in %) of Tanzania?
Keep it short and to the point. 8.06. 